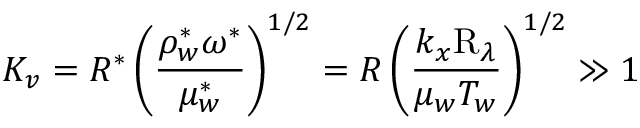Convert formula to latex. <formula><loc_0><loc_0><loc_500><loc_500>K _ { v } = R ^ { \ast } \left ( \frac { \rho _ { w } ^ { \ast } \omega ^ { \ast } } { \mu _ { w } ^ { \ast } } \right ) ^ { 1 / 2 } = R \left ( \frac { k _ { x } R _ { \lambda } } { \mu _ { w } T _ { w } } \right ) ^ { 1 / 2 } \gg 1</formula> 